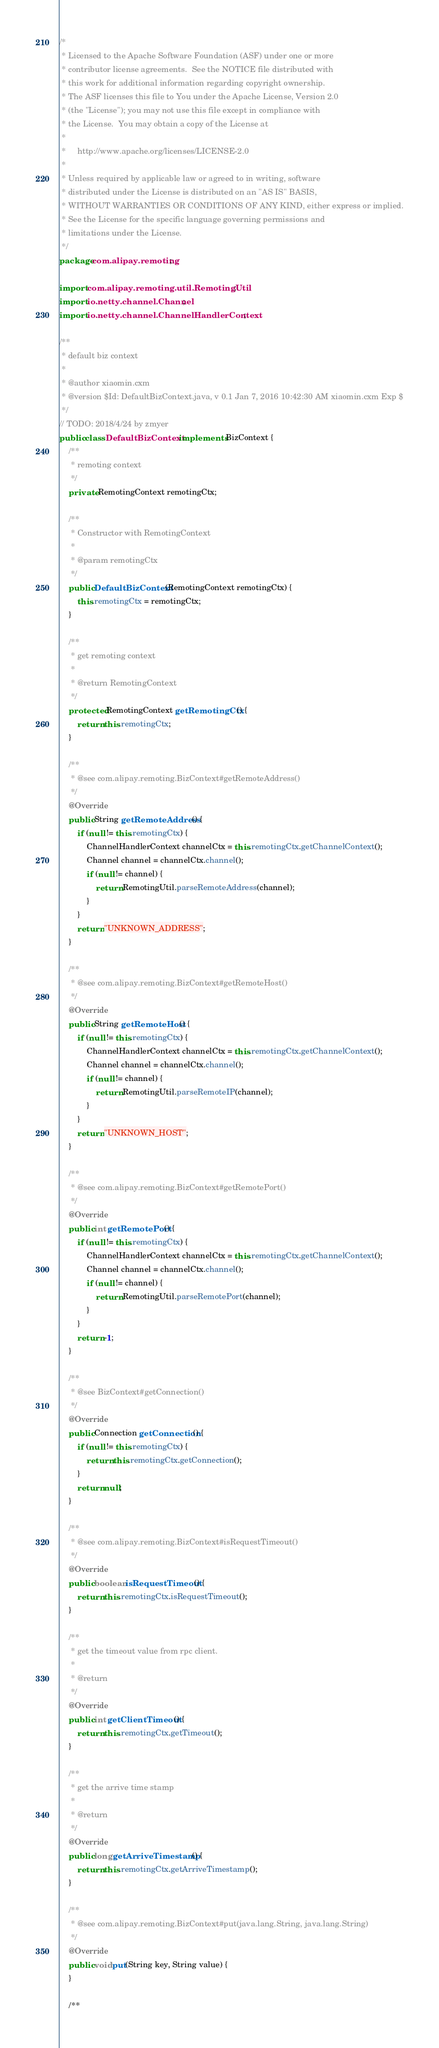Convert code to text. <code><loc_0><loc_0><loc_500><loc_500><_Java_>/*
 * Licensed to the Apache Software Foundation (ASF) under one or more
 * contributor license agreements.  See the NOTICE file distributed with
 * this work for additional information regarding copyright ownership.
 * The ASF licenses this file to You under the Apache License, Version 2.0
 * (the "License"); you may not use this file except in compliance with
 * the License.  You may obtain a copy of the License at
 *
 *     http://www.apache.org/licenses/LICENSE-2.0
 *
 * Unless required by applicable law or agreed to in writing, software
 * distributed under the License is distributed on an "AS IS" BASIS,
 * WITHOUT WARRANTIES OR CONDITIONS OF ANY KIND, either express or implied.
 * See the License for the specific language governing permissions and
 * limitations under the License.
 */
package com.alipay.remoting;

import com.alipay.remoting.util.RemotingUtil;
import io.netty.channel.Channel;
import io.netty.channel.ChannelHandlerContext;

/**
 * default biz context
 *
 * @author xiaomin.cxm
 * @version $Id: DefaultBizContext.java, v 0.1 Jan 7, 2016 10:42:30 AM xiaomin.cxm Exp $
 */
// TODO: 2018/4/24 by zmyer
public class DefaultBizContext implements BizContext {
    /**
     * remoting context
     */
    private RemotingContext remotingCtx;

    /**
     * Constructor with RemotingContext
     *
     * @param remotingCtx
     */
    public DefaultBizContext(RemotingContext remotingCtx) {
        this.remotingCtx = remotingCtx;
    }

    /**
     * get remoting context
     *
     * @return RemotingContext
     */
    protected RemotingContext getRemotingCtx() {
        return this.remotingCtx;
    }

    /**
     * @see com.alipay.remoting.BizContext#getRemoteAddress()
     */
    @Override
    public String getRemoteAddress() {
        if (null != this.remotingCtx) {
            ChannelHandlerContext channelCtx = this.remotingCtx.getChannelContext();
            Channel channel = channelCtx.channel();
            if (null != channel) {
                return RemotingUtil.parseRemoteAddress(channel);
            }
        }
        return "UNKNOWN_ADDRESS";
    }

    /**
     * @see com.alipay.remoting.BizContext#getRemoteHost()
     */
    @Override
    public String getRemoteHost() {
        if (null != this.remotingCtx) {
            ChannelHandlerContext channelCtx = this.remotingCtx.getChannelContext();
            Channel channel = channelCtx.channel();
            if (null != channel) {
                return RemotingUtil.parseRemoteIP(channel);
            }
        }
        return "UNKNOWN_HOST";
    }

    /**
     * @see com.alipay.remoting.BizContext#getRemotePort()
     */
    @Override
    public int getRemotePort() {
        if (null != this.remotingCtx) {
            ChannelHandlerContext channelCtx = this.remotingCtx.getChannelContext();
            Channel channel = channelCtx.channel();
            if (null != channel) {
                return RemotingUtil.parseRemotePort(channel);
            }
        }
        return -1;
    }

    /**
     * @see BizContext#getConnection()
     */
    @Override
    public Connection getConnection() {
        if (null != this.remotingCtx) {
            return this.remotingCtx.getConnection();
        }
        return null;
    }

    /**
     * @see com.alipay.remoting.BizContext#isRequestTimeout()
     */
    @Override
    public boolean isRequestTimeout() {
        return this.remotingCtx.isRequestTimeout();
    }

    /**
     * get the timeout value from rpc client.
     *
     * @return
     */
    @Override
    public int getClientTimeout() {
        return this.remotingCtx.getTimeout();
    }

    /**
     * get the arrive time stamp
     *
     * @return
     */
    @Override
    public long getArriveTimestamp() {
        return this.remotingCtx.getArriveTimestamp();
    }

    /**
     * @see com.alipay.remoting.BizContext#put(java.lang.String, java.lang.String)
     */
    @Override
    public void put(String key, String value) {
    }

    /**</code> 